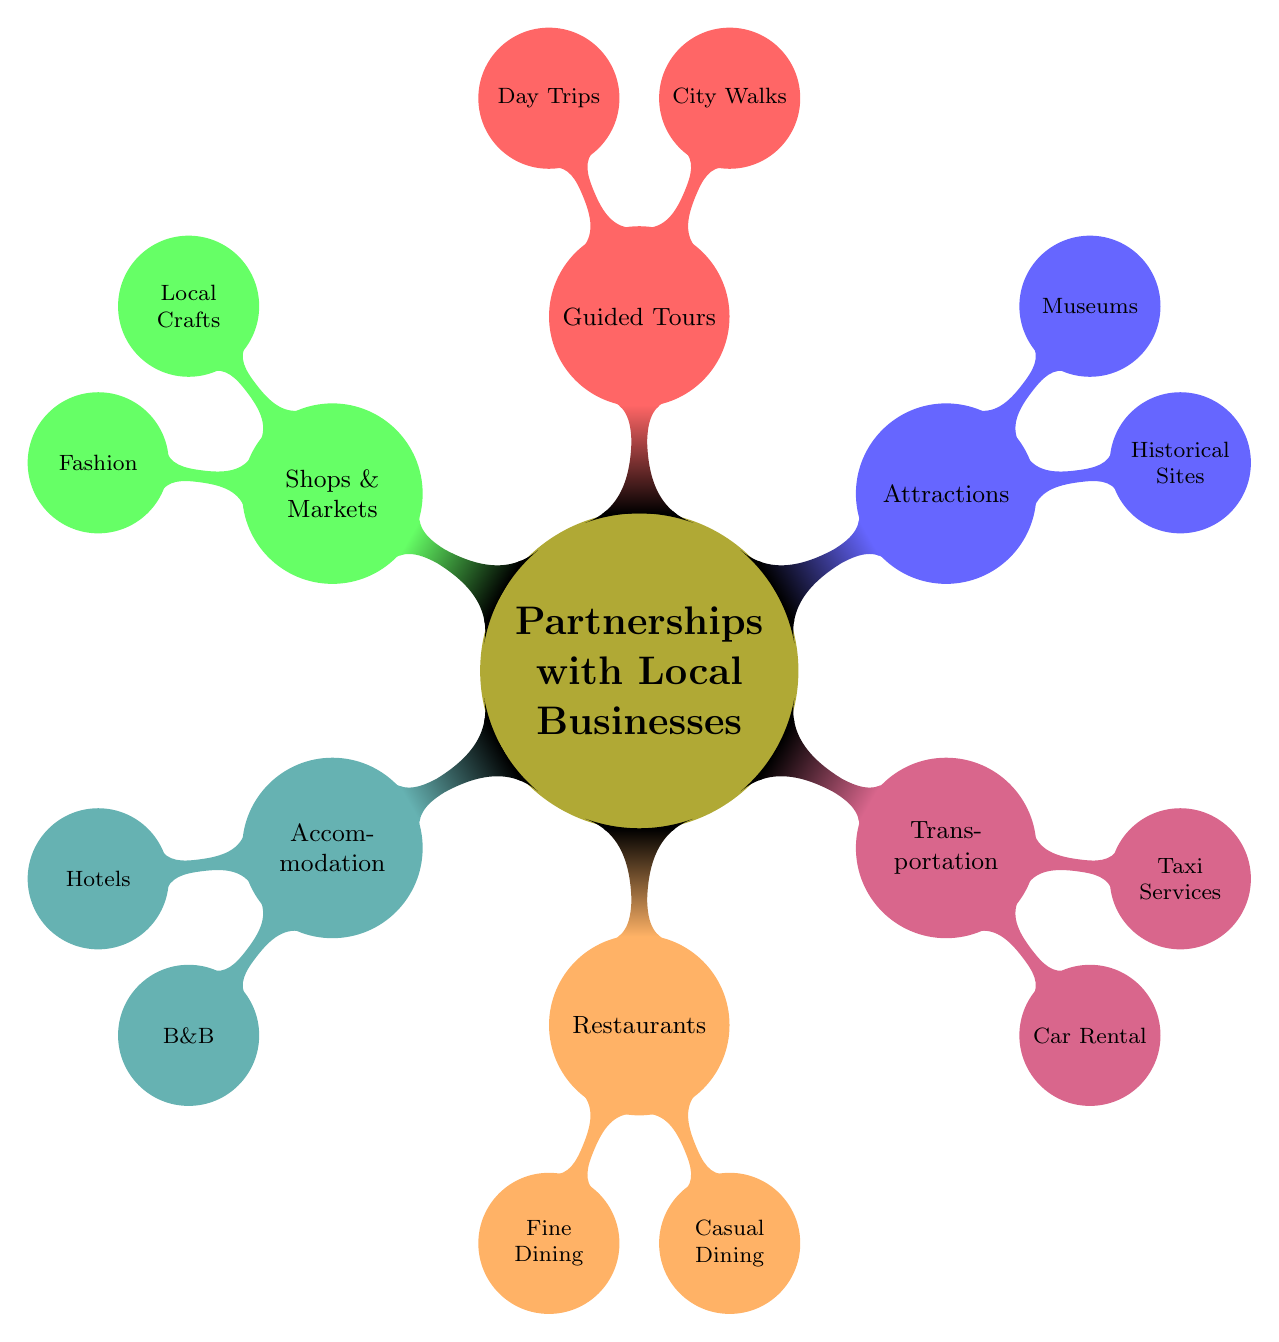What are the accommodation types listed? The mind map under the "Accommodation" node shows two types: "Hotels" and "BedAndBreakfast".
Answer: Hotels, BedAndBreakfast How many restaurants categories are in the diagram? There are two categories under the "Restaurants" node: "FineDining" and "CasualDining", which gives a total of 2 categories.
Answer: 2 Which local attraction falls under historical sites? Under the "Attractions" node, one of the historical sites listed is "Colosseum".
Answer: Colosseum What type of shops are mentioned in the diagram? The "ShopsAndMarkets" category includes types such as "LocalCrafts" and "Fashion".
Answer: LocalCrafts, Fashion Which transportation option has two subcategories? The "Transportation" node has two subcategories: "CarRental" and "TaxiServices".
Answer: Transportation Name a guided tour option available in the mind map. The "GuidedTours" node includes options like "CityWalks" which represents a type of guided tour available.
Answer: CityWalks Which two services provide car rental? Under the "CarRental" subcategory in "Transportation", the services listed are "Europcar" and "Hertz".
Answer: Europcar, Hertz How many nodes are under the "Restaurants" category? The "Restaurants" category includes two nodes: "FineDining" and "CasualDining", collectively providing two nodes under this category.
Answer: 2 Which museum is listed under attractions? Under the "Museums" subsection of "Attractions", "Uffizi Gallery" is mentioned as one of the museums.
Answer: Uffizi Gallery 